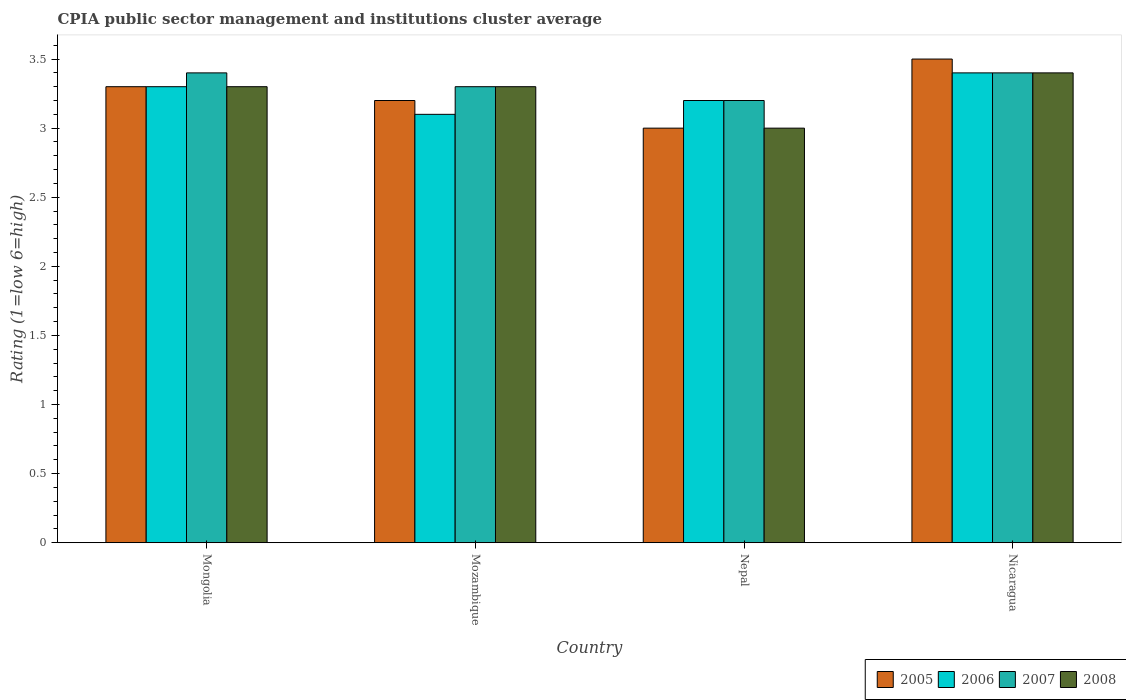How many groups of bars are there?
Ensure brevity in your answer.  4. Are the number of bars per tick equal to the number of legend labels?
Give a very brief answer. Yes. Are the number of bars on each tick of the X-axis equal?
Give a very brief answer. Yes. What is the label of the 2nd group of bars from the left?
Your answer should be compact. Mozambique. Across all countries, what is the maximum CPIA rating in 2005?
Provide a short and direct response. 3.5. Across all countries, what is the minimum CPIA rating in 2006?
Offer a very short reply. 3.1. In which country was the CPIA rating in 2007 maximum?
Make the answer very short. Mongolia. In which country was the CPIA rating in 2006 minimum?
Keep it short and to the point. Mozambique. What is the total CPIA rating in 2006 in the graph?
Your answer should be compact. 13. What is the difference between the CPIA rating in 2008 in Mongolia and that in Nepal?
Offer a terse response. 0.3. What is the average CPIA rating in 2008 per country?
Your response must be concise. 3.25. In how many countries, is the CPIA rating in 2005 greater than 0.6?
Provide a succinct answer. 4. What is the ratio of the CPIA rating in 2007 in Mongolia to that in Nepal?
Offer a terse response. 1.06. What is the difference between the highest and the second highest CPIA rating in 2006?
Offer a terse response. -0.1. What is the difference between the highest and the lowest CPIA rating in 2006?
Your response must be concise. 0.3. In how many countries, is the CPIA rating in 2008 greater than the average CPIA rating in 2008 taken over all countries?
Your response must be concise. 3. Is the sum of the CPIA rating in 2005 in Mozambique and Nepal greater than the maximum CPIA rating in 2007 across all countries?
Ensure brevity in your answer.  Yes. Is it the case that in every country, the sum of the CPIA rating in 2006 and CPIA rating in 2005 is greater than the CPIA rating in 2007?
Offer a very short reply. Yes. How many bars are there?
Your answer should be compact. 16. Are all the bars in the graph horizontal?
Your answer should be very brief. No. How many countries are there in the graph?
Provide a succinct answer. 4. What is the difference between two consecutive major ticks on the Y-axis?
Your answer should be very brief. 0.5. Are the values on the major ticks of Y-axis written in scientific E-notation?
Your response must be concise. No. Does the graph contain grids?
Give a very brief answer. No. How many legend labels are there?
Give a very brief answer. 4. How are the legend labels stacked?
Offer a terse response. Horizontal. What is the title of the graph?
Offer a very short reply. CPIA public sector management and institutions cluster average. Does "2003" appear as one of the legend labels in the graph?
Provide a succinct answer. No. What is the label or title of the Y-axis?
Offer a very short reply. Rating (1=low 6=high). What is the Rating (1=low 6=high) in 2006 in Mongolia?
Keep it short and to the point. 3.3. What is the Rating (1=low 6=high) in 2007 in Mongolia?
Offer a terse response. 3.4. What is the Rating (1=low 6=high) of 2006 in Mozambique?
Your response must be concise. 3.1. What is the Rating (1=low 6=high) of 2008 in Mozambique?
Provide a short and direct response. 3.3. What is the Rating (1=low 6=high) of 2007 in Nepal?
Provide a short and direct response. 3.2. What is the Rating (1=low 6=high) in 2005 in Nicaragua?
Ensure brevity in your answer.  3.5. What is the Rating (1=low 6=high) in 2006 in Nicaragua?
Your answer should be compact. 3.4. Across all countries, what is the maximum Rating (1=low 6=high) in 2005?
Your response must be concise. 3.5. Across all countries, what is the maximum Rating (1=low 6=high) of 2006?
Provide a short and direct response. 3.4. Across all countries, what is the minimum Rating (1=low 6=high) in 2005?
Provide a short and direct response. 3. Across all countries, what is the minimum Rating (1=low 6=high) of 2006?
Your answer should be compact. 3.1. Across all countries, what is the minimum Rating (1=low 6=high) in 2007?
Ensure brevity in your answer.  3.2. What is the difference between the Rating (1=low 6=high) in 2007 in Mongolia and that in Mozambique?
Offer a very short reply. 0.1. What is the difference between the Rating (1=low 6=high) of 2008 in Mongolia and that in Mozambique?
Give a very brief answer. 0. What is the difference between the Rating (1=low 6=high) in 2005 in Mongolia and that in Nepal?
Make the answer very short. 0.3. What is the difference between the Rating (1=low 6=high) in 2005 in Mongolia and that in Nicaragua?
Provide a succinct answer. -0.2. What is the difference between the Rating (1=low 6=high) of 2006 in Mongolia and that in Nicaragua?
Your answer should be very brief. -0.1. What is the difference between the Rating (1=low 6=high) in 2007 in Mongolia and that in Nicaragua?
Offer a very short reply. 0. What is the difference between the Rating (1=low 6=high) in 2008 in Mongolia and that in Nicaragua?
Your answer should be compact. -0.1. What is the difference between the Rating (1=low 6=high) of 2006 in Mozambique and that in Nepal?
Provide a short and direct response. -0.1. What is the difference between the Rating (1=low 6=high) of 2008 in Mozambique and that in Nepal?
Offer a very short reply. 0.3. What is the difference between the Rating (1=low 6=high) in 2006 in Mozambique and that in Nicaragua?
Your answer should be compact. -0.3. What is the difference between the Rating (1=low 6=high) in 2007 in Mozambique and that in Nicaragua?
Give a very brief answer. -0.1. What is the difference between the Rating (1=low 6=high) in 2008 in Mozambique and that in Nicaragua?
Ensure brevity in your answer.  -0.1. What is the difference between the Rating (1=low 6=high) of 2005 in Nepal and that in Nicaragua?
Your answer should be very brief. -0.5. What is the difference between the Rating (1=low 6=high) in 2006 in Nepal and that in Nicaragua?
Make the answer very short. -0.2. What is the difference between the Rating (1=low 6=high) of 2007 in Nepal and that in Nicaragua?
Give a very brief answer. -0.2. What is the difference between the Rating (1=low 6=high) of 2005 in Mongolia and the Rating (1=low 6=high) of 2008 in Mozambique?
Keep it short and to the point. 0. What is the difference between the Rating (1=low 6=high) of 2006 in Mongolia and the Rating (1=low 6=high) of 2008 in Mozambique?
Give a very brief answer. 0. What is the difference between the Rating (1=low 6=high) of 2005 in Mongolia and the Rating (1=low 6=high) of 2007 in Nepal?
Keep it short and to the point. 0.1. What is the difference between the Rating (1=low 6=high) of 2006 in Mongolia and the Rating (1=low 6=high) of 2007 in Nepal?
Provide a succinct answer. 0.1. What is the difference between the Rating (1=low 6=high) of 2007 in Mongolia and the Rating (1=low 6=high) of 2008 in Nepal?
Keep it short and to the point. 0.4. What is the difference between the Rating (1=low 6=high) in 2005 in Mongolia and the Rating (1=low 6=high) in 2006 in Nicaragua?
Offer a very short reply. -0.1. What is the difference between the Rating (1=low 6=high) of 2005 in Mongolia and the Rating (1=low 6=high) of 2007 in Nicaragua?
Your response must be concise. -0.1. What is the difference between the Rating (1=low 6=high) in 2005 in Mongolia and the Rating (1=low 6=high) in 2008 in Nicaragua?
Offer a very short reply. -0.1. What is the difference between the Rating (1=low 6=high) of 2006 in Mongolia and the Rating (1=low 6=high) of 2008 in Nicaragua?
Provide a short and direct response. -0.1. What is the difference between the Rating (1=low 6=high) of 2006 in Mozambique and the Rating (1=low 6=high) of 2007 in Nepal?
Offer a terse response. -0.1. What is the difference between the Rating (1=low 6=high) of 2007 in Mozambique and the Rating (1=low 6=high) of 2008 in Nepal?
Ensure brevity in your answer.  0.3. What is the difference between the Rating (1=low 6=high) in 2006 in Mozambique and the Rating (1=low 6=high) in 2008 in Nicaragua?
Your answer should be compact. -0.3. What is the difference between the Rating (1=low 6=high) of 2007 in Mozambique and the Rating (1=low 6=high) of 2008 in Nicaragua?
Provide a succinct answer. -0.1. What is the difference between the Rating (1=low 6=high) in 2005 in Nepal and the Rating (1=low 6=high) in 2006 in Nicaragua?
Make the answer very short. -0.4. What is the difference between the Rating (1=low 6=high) of 2005 in Nepal and the Rating (1=low 6=high) of 2007 in Nicaragua?
Offer a very short reply. -0.4. What is the difference between the Rating (1=low 6=high) of 2005 in Nepal and the Rating (1=low 6=high) of 2008 in Nicaragua?
Your answer should be very brief. -0.4. What is the difference between the Rating (1=low 6=high) of 2006 in Nepal and the Rating (1=low 6=high) of 2008 in Nicaragua?
Make the answer very short. -0.2. What is the average Rating (1=low 6=high) of 2005 per country?
Make the answer very short. 3.25. What is the average Rating (1=low 6=high) in 2006 per country?
Keep it short and to the point. 3.25. What is the average Rating (1=low 6=high) of 2007 per country?
Your response must be concise. 3.33. What is the average Rating (1=low 6=high) of 2008 per country?
Give a very brief answer. 3.25. What is the difference between the Rating (1=low 6=high) in 2005 and Rating (1=low 6=high) in 2006 in Mongolia?
Offer a very short reply. 0. What is the difference between the Rating (1=low 6=high) of 2006 and Rating (1=low 6=high) of 2008 in Mongolia?
Provide a short and direct response. 0. What is the difference between the Rating (1=low 6=high) of 2005 and Rating (1=low 6=high) of 2007 in Mozambique?
Your answer should be very brief. -0.1. What is the difference between the Rating (1=low 6=high) of 2006 and Rating (1=low 6=high) of 2007 in Mozambique?
Ensure brevity in your answer.  -0.2. What is the difference between the Rating (1=low 6=high) of 2006 and Rating (1=low 6=high) of 2008 in Mozambique?
Your answer should be very brief. -0.2. What is the difference between the Rating (1=low 6=high) in 2007 and Rating (1=low 6=high) in 2008 in Mozambique?
Your answer should be very brief. 0. What is the difference between the Rating (1=low 6=high) in 2005 and Rating (1=low 6=high) in 2006 in Nepal?
Ensure brevity in your answer.  -0.2. What is the difference between the Rating (1=low 6=high) in 2005 and Rating (1=low 6=high) in 2007 in Nepal?
Your answer should be very brief. -0.2. What is the difference between the Rating (1=low 6=high) in 2005 and Rating (1=low 6=high) in 2006 in Nicaragua?
Make the answer very short. 0.1. What is the difference between the Rating (1=low 6=high) in 2005 and Rating (1=low 6=high) in 2007 in Nicaragua?
Your response must be concise. 0.1. What is the difference between the Rating (1=low 6=high) in 2005 and Rating (1=low 6=high) in 2008 in Nicaragua?
Your answer should be compact. 0.1. What is the difference between the Rating (1=low 6=high) of 2006 and Rating (1=low 6=high) of 2008 in Nicaragua?
Provide a short and direct response. 0. What is the ratio of the Rating (1=low 6=high) in 2005 in Mongolia to that in Mozambique?
Your answer should be compact. 1.03. What is the ratio of the Rating (1=low 6=high) of 2006 in Mongolia to that in Mozambique?
Give a very brief answer. 1.06. What is the ratio of the Rating (1=low 6=high) of 2007 in Mongolia to that in Mozambique?
Offer a very short reply. 1.03. What is the ratio of the Rating (1=low 6=high) in 2005 in Mongolia to that in Nepal?
Your answer should be compact. 1.1. What is the ratio of the Rating (1=low 6=high) of 2006 in Mongolia to that in Nepal?
Your response must be concise. 1.03. What is the ratio of the Rating (1=low 6=high) in 2005 in Mongolia to that in Nicaragua?
Offer a terse response. 0.94. What is the ratio of the Rating (1=low 6=high) of 2006 in Mongolia to that in Nicaragua?
Your answer should be very brief. 0.97. What is the ratio of the Rating (1=low 6=high) of 2007 in Mongolia to that in Nicaragua?
Your answer should be very brief. 1. What is the ratio of the Rating (1=low 6=high) in 2008 in Mongolia to that in Nicaragua?
Keep it short and to the point. 0.97. What is the ratio of the Rating (1=low 6=high) in 2005 in Mozambique to that in Nepal?
Keep it short and to the point. 1.07. What is the ratio of the Rating (1=low 6=high) in 2006 in Mozambique to that in Nepal?
Give a very brief answer. 0.97. What is the ratio of the Rating (1=low 6=high) of 2007 in Mozambique to that in Nepal?
Give a very brief answer. 1.03. What is the ratio of the Rating (1=low 6=high) in 2008 in Mozambique to that in Nepal?
Your answer should be compact. 1.1. What is the ratio of the Rating (1=low 6=high) of 2005 in Mozambique to that in Nicaragua?
Offer a very short reply. 0.91. What is the ratio of the Rating (1=low 6=high) in 2006 in Mozambique to that in Nicaragua?
Make the answer very short. 0.91. What is the ratio of the Rating (1=low 6=high) in 2007 in Mozambique to that in Nicaragua?
Offer a very short reply. 0.97. What is the ratio of the Rating (1=low 6=high) of 2008 in Mozambique to that in Nicaragua?
Your response must be concise. 0.97. What is the ratio of the Rating (1=low 6=high) in 2007 in Nepal to that in Nicaragua?
Ensure brevity in your answer.  0.94. What is the ratio of the Rating (1=low 6=high) in 2008 in Nepal to that in Nicaragua?
Ensure brevity in your answer.  0.88. What is the difference between the highest and the second highest Rating (1=low 6=high) of 2005?
Offer a very short reply. 0.2. 